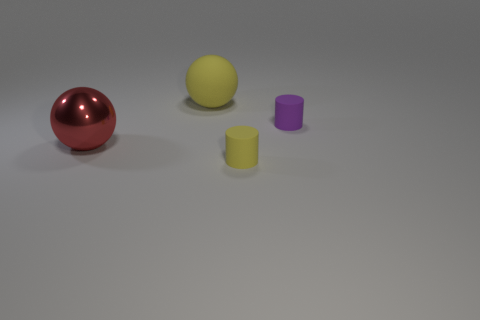What is the size of the rubber object behind the matte cylinder behind the small matte object that is in front of the red metallic thing?
Your response must be concise. Large. How many other objects are the same shape as the tiny purple object?
Offer a terse response. 1. There is a ball behind the purple rubber thing; is it the same color as the big object that is in front of the large yellow matte object?
Offer a terse response. No. There is a ball that is the same size as the red metal thing; what color is it?
Your answer should be very brief. Yellow. Are there any spheres that have the same color as the metal object?
Your answer should be very brief. No. There is a yellow matte object that is in front of the red thing; is its size the same as the big yellow object?
Keep it short and to the point. No. Are there the same number of small cylinders that are on the left side of the big yellow sphere and tiny things?
Provide a succinct answer. No. What number of things are either yellow things that are behind the tiny yellow rubber object or large metal cubes?
Give a very brief answer. 1. What shape is the thing that is in front of the small purple rubber object and to the right of the large red shiny sphere?
Your response must be concise. Cylinder. How many things are either large spheres behind the purple cylinder or big spheres behind the big red metal object?
Offer a terse response. 1. 